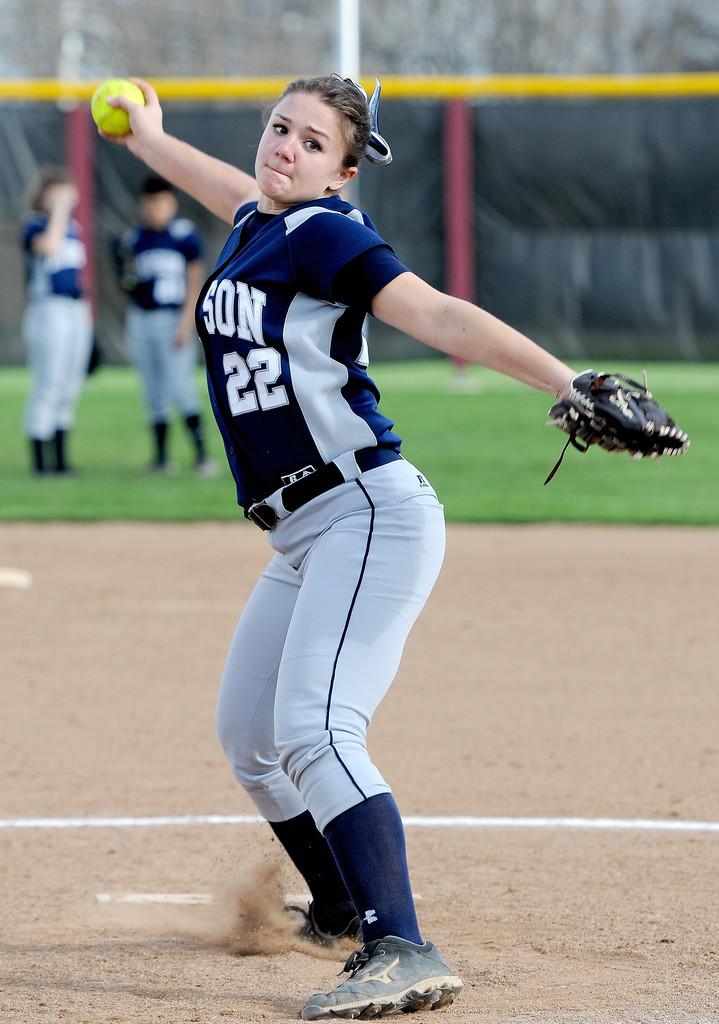What are the three letters visible on the woman's jersey?
Give a very brief answer. Son. 